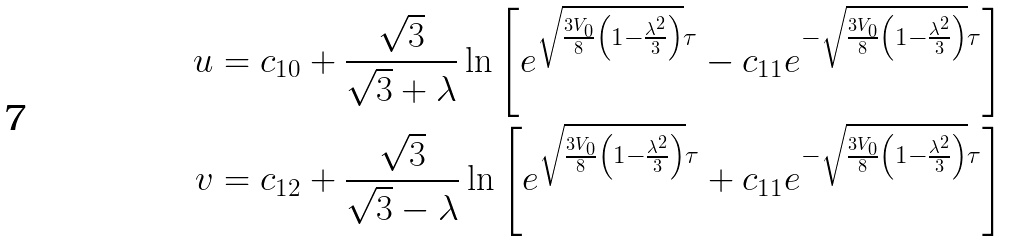Convert formula to latex. <formula><loc_0><loc_0><loc_500><loc_500>u & = c _ { 1 0 } + \frac { \sqrt { 3 } } { \sqrt { 3 } + \lambda } \ln \left [ e ^ { \sqrt { \frac { 3 V _ { 0 } } { 8 } \left ( 1 - \frac { \lambda ^ { 2 } } { 3 } \right ) } \tau } - c _ { 1 1 } e ^ { - \sqrt { \frac { 3 V _ { 0 } } { 8 } \left ( 1 - \frac { \lambda ^ { 2 } } { 3 } \right ) } \tau } \right ] \\ v & = c _ { 1 2 } + \frac { \sqrt { 3 } } { \sqrt { 3 } - \lambda } \ln \left [ e ^ { \sqrt { \frac { 3 V _ { 0 } } { 8 } \left ( 1 - \frac { \lambda ^ { 2 } } { 3 } \right ) } \tau } + c _ { 1 1 } e ^ { - \sqrt { \frac { 3 V _ { 0 } } { 8 } \left ( 1 - \frac { \lambda ^ { 2 } } { 3 } \right ) } \tau } \right ]</formula> 